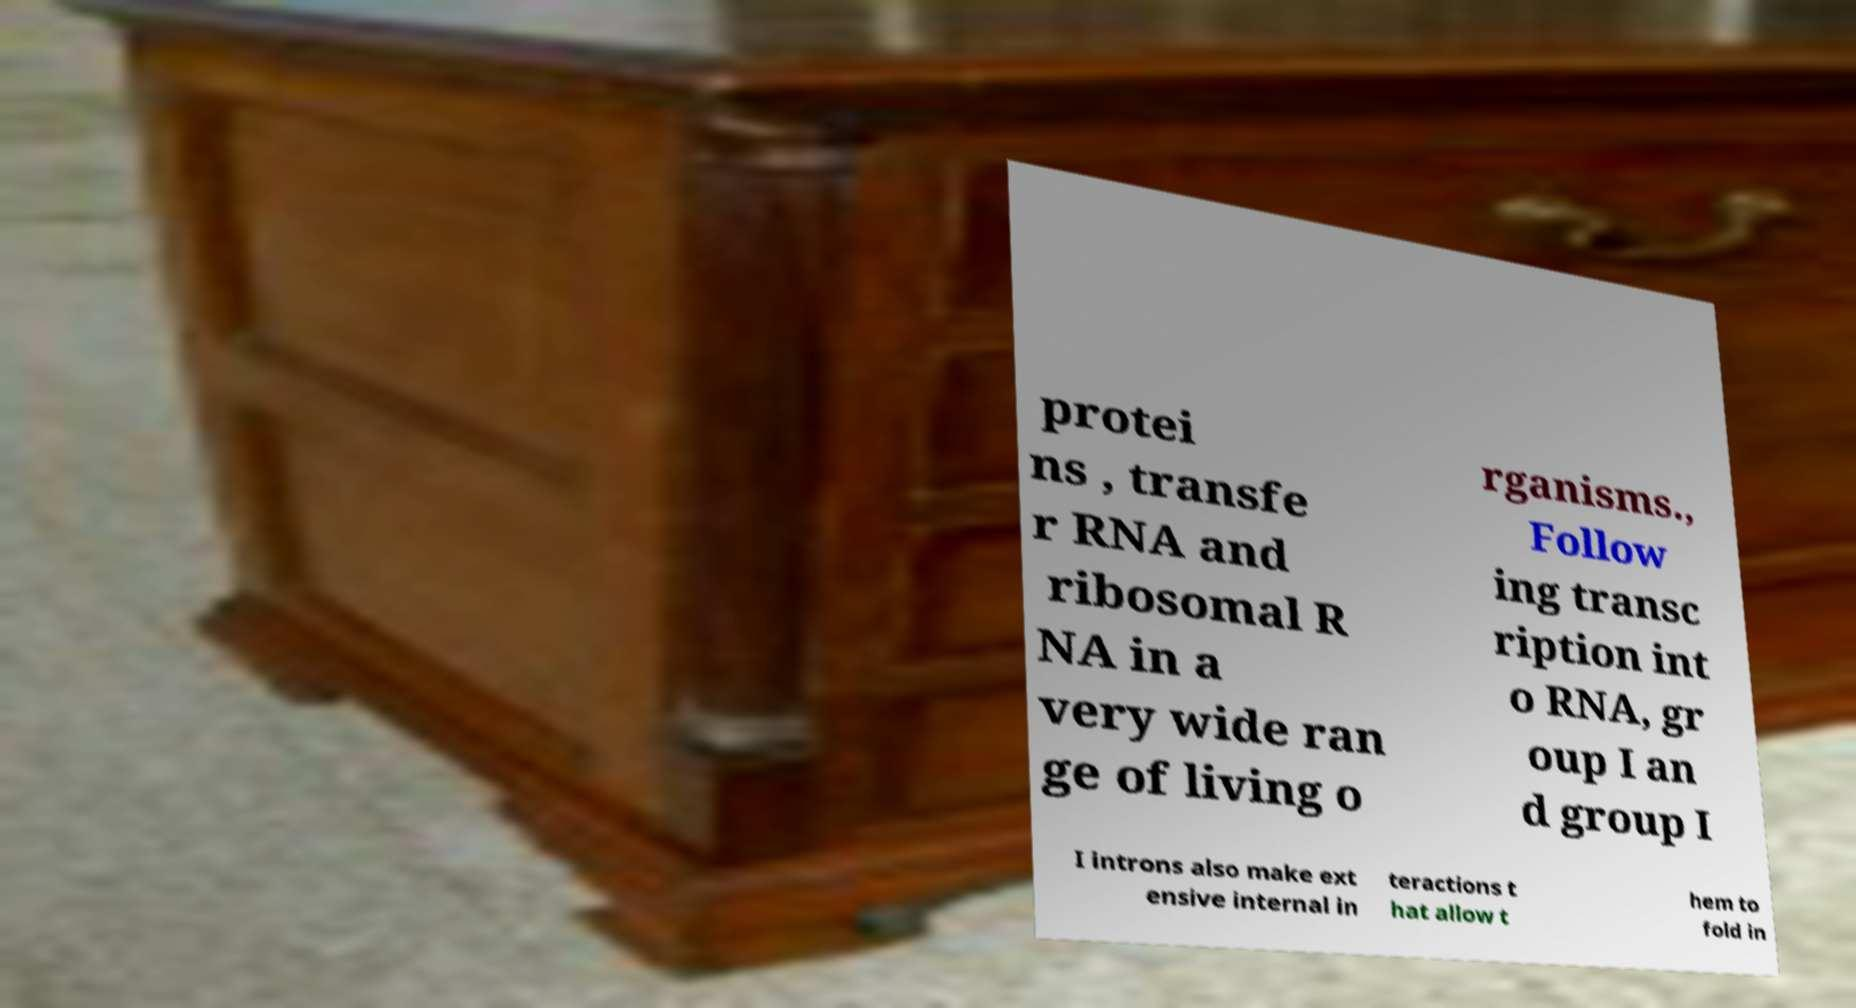For documentation purposes, I need the text within this image transcribed. Could you provide that? protei ns , transfe r RNA and ribosomal R NA in a very wide ran ge of living o rganisms., Follow ing transc ription int o RNA, gr oup I an d group I I introns also make ext ensive internal in teractions t hat allow t hem to fold in 